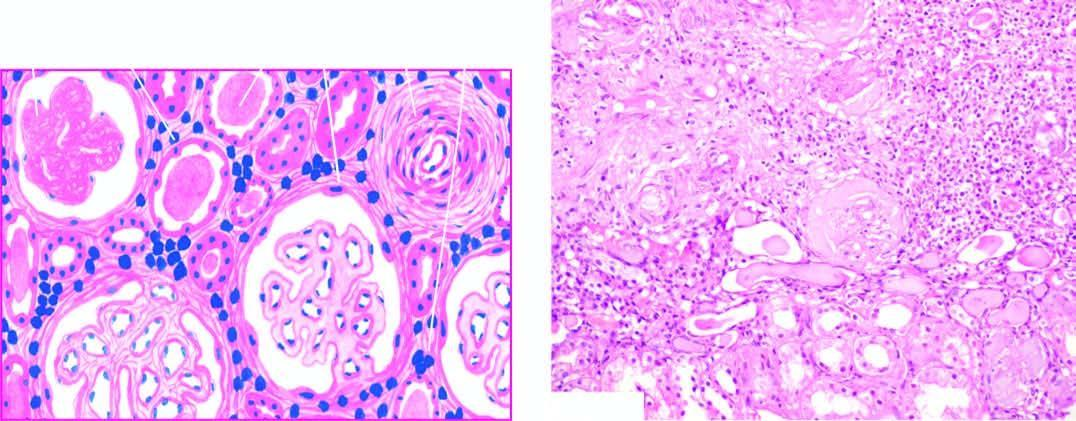do the glomeruli show periglomerular fibrosis?
Answer the question using a single word or phrase. Yes 